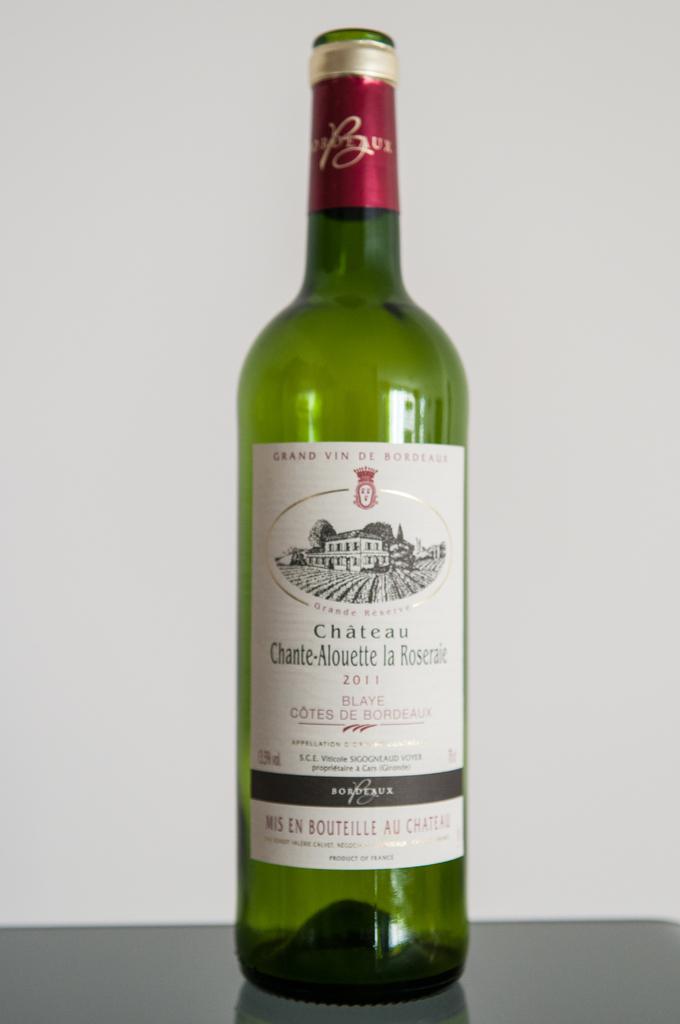What kind of wine does the label say it is in the wine bottle?
Provide a short and direct response. Chateau. In what year was this wine bottled?
Your response must be concise. 2011. 